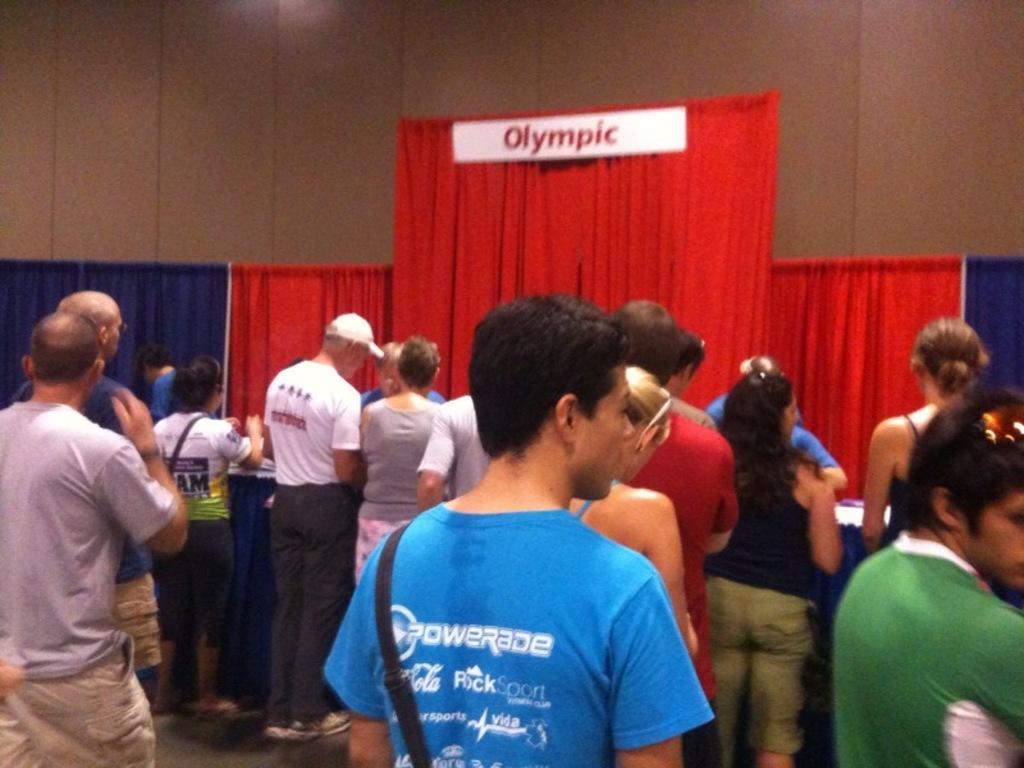Describe this image in one or two sentences. In this image there are so many people standing on the floor. In front of them there is a curtain on which there is a board. On the left side there are two curtains in front of them. There are few people standing near the table and talking with the persons who are wearing the blue colour t-shirt. In the background there is wall. 